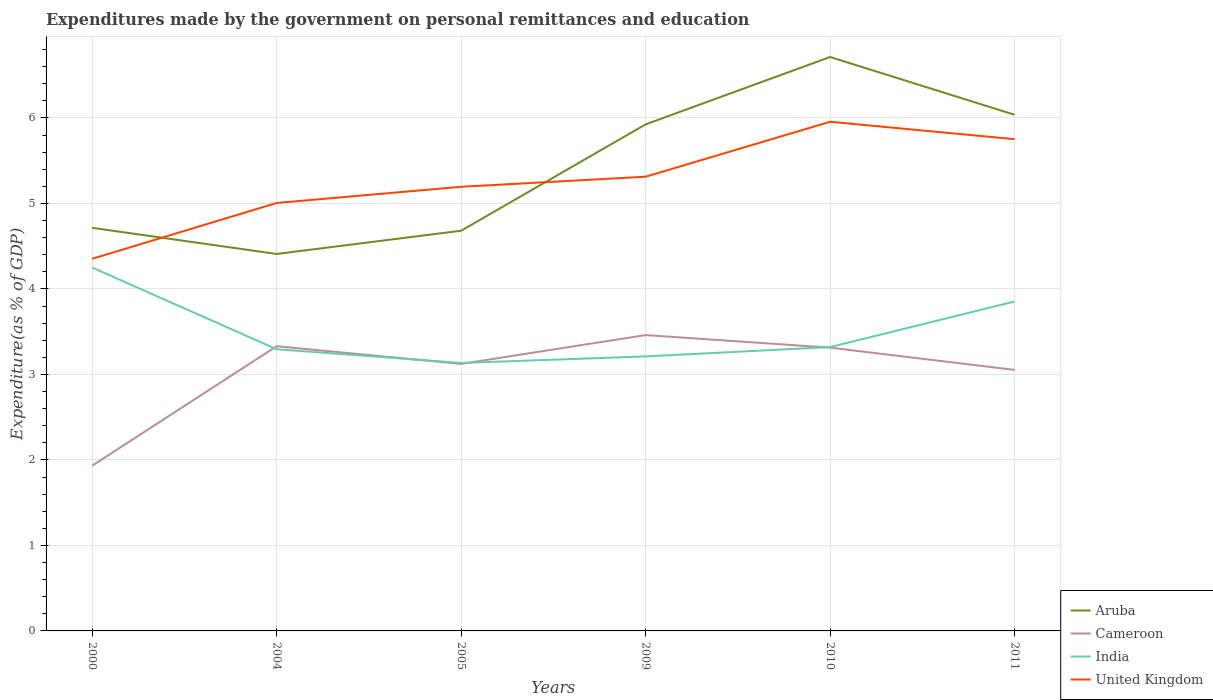How many different coloured lines are there?
Your response must be concise. 4. Across all years, what is the maximum expenditures made by the government on personal remittances and education in United Kingdom?
Your answer should be very brief. 4.35. In which year was the expenditures made by the government on personal remittances and education in India maximum?
Provide a short and direct response. 2005. What is the total expenditures made by the government on personal remittances and education in India in the graph?
Ensure brevity in your answer.  -0.11. What is the difference between the highest and the second highest expenditures made by the government on personal remittances and education in Cameroon?
Provide a succinct answer. 1.53. Is the expenditures made by the government on personal remittances and education in Cameroon strictly greater than the expenditures made by the government on personal remittances and education in India over the years?
Keep it short and to the point. No. How many lines are there?
Keep it short and to the point. 4. What is the difference between two consecutive major ticks on the Y-axis?
Ensure brevity in your answer.  1. Does the graph contain any zero values?
Your answer should be very brief. No. Where does the legend appear in the graph?
Give a very brief answer. Bottom right. How are the legend labels stacked?
Provide a succinct answer. Vertical. What is the title of the graph?
Offer a very short reply. Expenditures made by the government on personal remittances and education. Does "Ukraine" appear as one of the legend labels in the graph?
Ensure brevity in your answer.  No. What is the label or title of the X-axis?
Your answer should be compact. Years. What is the label or title of the Y-axis?
Offer a very short reply. Expenditure(as % of GDP). What is the Expenditure(as % of GDP) in Aruba in 2000?
Offer a very short reply. 4.71. What is the Expenditure(as % of GDP) in Cameroon in 2000?
Your answer should be very brief. 1.93. What is the Expenditure(as % of GDP) of India in 2000?
Give a very brief answer. 4.25. What is the Expenditure(as % of GDP) of United Kingdom in 2000?
Give a very brief answer. 4.35. What is the Expenditure(as % of GDP) in Aruba in 2004?
Provide a short and direct response. 4.41. What is the Expenditure(as % of GDP) of Cameroon in 2004?
Your answer should be very brief. 3.33. What is the Expenditure(as % of GDP) in India in 2004?
Make the answer very short. 3.29. What is the Expenditure(as % of GDP) in United Kingdom in 2004?
Provide a short and direct response. 5.01. What is the Expenditure(as % of GDP) of Aruba in 2005?
Ensure brevity in your answer.  4.68. What is the Expenditure(as % of GDP) of Cameroon in 2005?
Keep it short and to the point. 3.12. What is the Expenditure(as % of GDP) of India in 2005?
Offer a very short reply. 3.13. What is the Expenditure(as % of GDP) in United Kingdom in 2005?
Your answer should be compact. 5.19. What is the Expenditure(as % of GDP) in Aruba in 2009?
Give a very brief answer. 5.92. What is the Expenditure(as % of GDP) of Cameroon in 2009?
Ensure brevity in your answer.  3.46. What is the Expenditure(as % of GDP) of India in 2009?
Provide a succinct answer. 3.21. What is the Expenditure(as % of GDP) in United Kingdom in 2009?
Make the answer very short. 5.31. What is the Expenditure(as % of GDP) in Aruba in 2010?
Provide a short and direct response. 6.71. What is the Expenditure(as % of GDP) in Cameroon in 2010?
Your response must be concise. 3.31. What is the Expenditure(as % of GDP) in India in 2010?
Give a very brief answer. 3.32. What is the Expenditure(as % of GDP) of United Kingdom in 2010?
Provide a short and direct response. 5.95. What is the Expenditure(as % of GDP) of Aruba in 2011?
Offer a terse response. 6.04. What is the Expenditure(as % of GDP) of Cameroon in 2011?
Provide a succinct answer. 3.05. What is the Expenditure(as % of GDP) in India in 2011?
Provide a short and direct response. 3.85. What is the Expenditure(as % of GDP) of United Kingdom in 2011?
Your answer should be compact. 5.75. Across all years, what is the maximum Expenditure(as % of GDP) of Aruba?
Your answer should be compact. 6.71. Across all years, what is the maximum Expenditure(as % of GDP) in Cameroon?
Make the answer very short. 3.46. Across all years, what is the maximum Expenditure(as % of GDP) of India?
Your response must be concise. 4.25. Across all years, what is the maximum Expenditure(as % of GDP) in United Kingdom?
Offer a terse response. 5.95. Across all years, what is the minimum Expenditure(as % of GDP) in Aruba?
Your response must be concise. 4.41. Across all years, what is the minimum Expenditure(as % of GDP) in Cameroon?
Your response must be concise. 1.93. Across all years, what is the minimum Expenditure(as % of GDP) in India?
Offer a terse response. 3.13. Across all years, what is the minimum Expenditure(as % of GDP) of United Kingdom?
Make the answer very short. 4.35. What is the total Expenditure(as % of GDP) in Aruba in the graph?
Ensure brevity in your answer.  32.48. What is the total Expenditure(as % of GDP) of Cameroon in the graph?
Keep it short and to the point. 18.21. What is the total Expenditure(as % of GDP) of India in the graph?
Give a very brief answer. 21.06. What is the total Expenditure(as % of GDP) of United Kingdom in the graph?
Keep it short and to the point. 31.57. What is the difference between the Expenditure(as % of GDP) of Aruba in 2000 and that in 2004?
Your answer should be compact. 0.31. What is the difference between the Expenditure(as % of GDP) in Cameroon in 2000 and that in 2004?
Offer a very short reply. -1.4. What is the difference between the Expenditure(as % of GDP) in India in 2000 and that in 2004?
Your answer should be compact. 0.96. What is the difference between the Expenditure(as % of GDP) in United Kingdom in 2000 and that in 2004?
Give a very brief answer. -0.65. What is the difference between the Expenditure(as % of GDP) in Aruba in 2000 and that in 2005?
Your answer should be compact. 0.03. What is the difference between the Expenditure(as % of GDP) in Cameroon in 2000 and that in 2005?
Provide a short and direct response. -1.19. What is the difference between the Expenditure(as % of GDP) in India in 2000 and that in 2005?
Your response must be concise. 1.12. What is the difference between the Expenditure(as % of GDP) in United Kingdom in 2000 and that in 2005?
Ensure brevity in your answer.  -0.84. What is the difference between the Expenditure(as % of GDP) of Aruba in 2000 and that in 2009?
Your answer should be very brief. -1.21. What is the difference between the Expenditure(as % of GDP) in Cameroon in 2000 and that in 2009?
Make the answer very short. -1.53. What is the difference between the Expenditure(as % of GDP) in India in 2000 and that in 2009?
Your answer should be compact. 1.04. What is the difference between the Expenditure(as % of GDP) of United Kingdom in 2000 and that in 2009?
Ensure brevity in your answer.  -0.96. What is the difference between the Expenditure(as % of GDP) in Aruba in 2000 and that in 2010?
Your answer should be compact. -2. What is the difference between the Expenditure(as % of GDP) in Cameroon in 2000 and that in 2010?
Your response must be concise. -1.38. What is the difference between the Expenditure(as % of GDP) of India in 2000 and that in 2010?
Your response must be concise. 0.93. What is the difference between the Expenditure(as % of GDP) in United Kingdom in 2000 and that in 2010?
Ensure brevity in your answer.  -1.6. What is the difference between the Expenditure(as % of GDP) of Aruba in 2000 and that in 2011?
Offer a very short reply. -1.32. What is the difference between the Expenditure(as % of GDP) in Cameroon in 2000 and that in 2011?
Your answer should be very brief. -1.12. What is the difference between the Expenditure(as % of GDP) of India in 2000 and that in 2011?
Make the answer very short. 0.4. What is the difference between the Expenditure(as % of GDP) of United Kingdom in 2000 and that in 2011?
Your response must be concise. -1.4. What is the difference between the Expenditure(as % of GDP) of Aruba in 2004 and that in 2005?
Provide a succinct answer. -0.27. What is the difference between the Expenditure(as % of GDP) of Cameroon in 2004 and that in 2005?
Your response must be concise. 0.21. What is the difference between the Expenditure(as % of GDP) in India in 2004 and that in 2005?
Your response must be concise. 0.16. What is the difference between the Expenditure(as % of GDP) in United Kingdom in 2004 and that in 2005?
Offer a terse response. -0.19. What is the difference between the Expenditure(as % of GDP) in Aruba in 2004 and that in 2009?
Make the answer very short. -1.52. What is the difference between the Expenditure(as % of GDP) in Cameroon in 2004 and that in 2009?
Offer a terse response. -0.13. What is the difference between the Expenditure(as % of GDP) in India in 2004 and that in 2009?
Make the answer very short. 0.08. What is the difference between the Expenditure(as % of GDP) of United Kingdom in 2004 and that in 2009?
Keep it short and to the point. -0.31. What is the difference between the Expenditure(as % of GDP) in Aruba in 2004 and that in 2010?
Keep it short and to the point. -2.3. What is the difference between the Expenditure(as % of GDP) of Cameroon in 2004 and that in 2010?
Ensure brevity in your answer.  0.02. What is the difference between the Expenditure(as % of GDP) in India in 2004 and that in 2010?
Provide a succinct answer. -0.02. What is the difference between the Expenditure(as % of GDP) in United Kingdom in 2004 and that in 2010?
Your answer should be very brief. -0.95. What is the difference between the Expenditure(as % of GDP) of Aruba in 2004 and that in 2011?
Your answer should be compact. -1.63. What is the difference between the Expenditure(as % of GDP) of Cameroon in 2004 and that in 2011?
Keep it short and to the point. 0.28. What is the difference between the Expenditure(as % of GDP) of India in 2004 and that in 2011?
Offer a terse response. -0.56. What is the difference between the Expenditure(as % of GDP) in United Kingdom in 2004 and that in 2011?
Make the answer very short. -0.75. What is the difference between the Expenditure(as % of GDP) in Aruba in 2005 and that in 2009?
Provide a succinct answer. -1.24. What is the difference between the Expenditure(as % of GDP) of Cameroon in 2005 and that in 2009?
Give a very brief answer. -0.34. What is the difference between the Expenditure(as % of GDP) in India in 2005 and that in 2009?
Provide a short and direct response. -0.08. What is the difference between the Expenditure(as % of GDP) of United Kingdom in 2005 and that in 2009?
Provide a succinct answer. -0.12. What is the difference between the Expenditure(as % of GDP) in Aruba in 2005 and that in 2010?
Your answer should be compact. -2.03. What is the difference between the Expenditure(as % of GDP) in Cameroon in 2005 and that in 2010?
Offer a terse response. -0.19. What is the difference between the Expenditure(as % of GDP) of India in 2005 and that in 2010?
Your answer should be very brief. -0.19. What is the difference between the Expenditure(as % of GDP) in United Kingdom in 2005 and that in 2010?
Ensure brevity in your answer.  -0.76. What is the difference between the Expenditure(as % of GDP) of Aruba in 2005 and that in 2011?
Provide a short and direct response. -1.36. What is the difference between the Expenditure(as % of GDP) of Cameroon in 2005 and that in 2011?
Provide a short and direct response. 0.07. What is the difference between the Expenditure(as % of GDP) of India in 2005 and that in 2011?
Make the answer very short. -0.72. What is the difference between the Expenditure(as % of GDP) of United Kingdom in 2005 and that in 2011?
Your answer should be compact. -0.56. What is the difference between the Expenditure(as % of GDP) of Aruba in 2009 and that in 2010?
Provide a succinct answer. -0.79. What is the difference between the Expenditure(as % of GDP) of Cameroon in 2009 and that in 2010?
Provide a succinct answer. 0.15. What is the difference between the Expenditure(as % of GDP) in India in 2009 and that in 2010?
Ensure brevity in your answer.  -0.11. What is the difference between the Expenditure(as % of GDP) in United Kingdom in 2009 and that in 2010?
Provide a succinct answer. -0.64. What is the difference between the Expenditure(as % of GDP) in Aruba in 2009 and that in 2011?
Ensure brevity in your answer.  -0.11. What is the difference between the Expenditure(as % of GDP) in Cameroon in 2009 and that in 2011?
Provide a succinct answer. 0.41. What is the difference between the Expenditure(as % of GDP) of India in 2009 and that in 2011?
Keep it short and to the point. -0.64. What is the difference between the Expenditure(as % of GDP) of United Kingdom in 2009 and that in 2011?
Offer a very short reply. -0.44. What is the difference between the Expenditure(as % of GDP) of Aruba in 2010 and that in 2011?
Give a very brief answer. 0.68. What is the difference between the Expenditure(as % of GDP) in Cameroon in 2010 and that in 2011?
Give a very brief answer. 0.26. What is the difference between the Expenditure(as % of GDP) in India in 2010 and that in 2011?
Make the answer very short. -0.53. What is the difference between the Expenditure(as % of GDP) in United Kingdom in 2010 and that in 2011?
Make the answer very short. 0.2. What is the difference between the Expenditure(as % of GDP) in Aruba in 2000 and the Expenditure(as % of GDP) in Cameroon in 2004?
Your answer should be compact. 1.38. What is the difference between the Expenditure(as % of GDP) in Aruba in 2000 and the Expenditure(as % of GDP) in India in 2004?
Your answer should be compact. 1.42. What is the difference between the Expenditure(as % of GDP) in Aruba in 2000 and the Expenditure(as % of GDP) in United Kingdom in 2004?
Offer a terse response. -0.29. What is the difference between the Expenditure(as % of GDP) in Cameroon in 2000 and the Expenditure(as % of GDP) in India in 2004?
Your response must be concise. -1.36. What is the difference between the Expenditure(as % of GDP) of Cameroon in 2000 and the Expenditure(as % of GDP) of United Kingdom in 2004?
Provide a short and direct response. -3.07. What is the difference between the Expenditure(as % of GDP) of India in 2000 and the Expenditure(as % of GDP) of United Kingdom in 2004?
Give a very brief answer. -0.76. What is the difference between the Expenditure(as % of GDP) of Aruba in 2000 and the Expenditure(as % of GDP) of Cameroon in 2005?
Your answer should be compact. 1.59. What is the difference between the Expenditure(as % of GDP) in Aruba in 2000 and the Expenditure(as % of GDP) in India in 2005?
Offer a very short reply. 1.58. What is the difference between the Expenditure(as % of GDP) of Aruba in 2000 and the Expenditure(as % of GDP) of United Kingdom in 2005?
Offer a very short reply. -0.48. What is the difference between the Expenditure(as % of GDP) of Cameroon in 2000 and the Expenditure(as % of GDP) of India in 2005?
Offer a terse response. -1.2. What is the difference between the Expenditure(as % of GDP) in Cameroon in 2000 and the Expenditure(as % of GDP) in United Kingdom in 2005?
Provide a short and direct response. -3.26. What is the difference between the Expenditure(as % of GDP) in India in 2000 and the Expenditure(as % of GDP) in United Kingdom in 2005?
Offer a terse response. -0.94. What is the difference between the Expenditure(as % of GDP) of Aruba in 2000 and the Expenditure(as % of GDP) of Cameroon in 2009?
Make the answer very short. 1.25. What is the difference between the Expenditure(as % of GDP) in Aruba in 2000 and the Expenditure(as % of GDP) in India in 2009?
Provide a short and direct response. 1.5. What is the difference between the Expenditure(as % of GDP) in Aruba in 2000 and the Expenditure(as % of GDP) in United Kingdom in 2009?
Your answer should be compact. -0.6. What is the difference between the Expenditure(as % of GDP) in Cameroon in 2000 and the Expenditure(as % of GDP) in India in 2009?
Offer a terse response. -1.28. What is the difference between the Expenditure(as % of GDP) of Cameroon in 2000 and the Expenditure(as % of GDP) of United Kingdom in 2009?
Provide a short and direct response. -3.38. What is the difference between the Expenditure(as % of GDP) in India in 2000 and the Expenditure(as % of GDP) in United Kingdom in 2009?
Ensure brevity in your answer.  -1.06. What is the difference between the Expenditure(as % of GDP) of Aruba in 2000 and the Expenditure(as % of GDP) of Cameroon in 2010?
Offer a very short reply. 1.4. What is the difference between the Expenditure(as % of GDP) in Aruba in 2000 and the Expenditure(as % of GDP) in India in 2010?
Offer a terse response. 1.4. What is the difference between the Expenditure(as % of GDP) of Aruba in 2000 and the Expenditure(as % of GDP) of United Kingdom in 2010?
Your answer should be very brief. -1.24. What is the difference between the Expenditure(as % of GDP) of Cameroon in 2000 and the Expenditure(as % of GDP) of India in 2010?
Offer a very short reply. -1.39. What is the difference between the Expenditure(as % of GDP) of Cameroon in 2000 and the Expenditure(as % of GDP) of United Kingdom in 2010?
Provide a short and direct response. -4.02. What is the difference between the Expenditure(as % of GDP) in India in 2000 and the Expenditure(as % of GDP) in United Kingdom in 2010?
Offer a very short reply. -1.7. What is the difference between the Expenditure(as % of GDP) of Aruba in 2000 and the Expenditure(as % of GDP) of Cameroon in 2011?
Provide a short and direct response. 1.66. What is the difference between the Expenditure(as % of GDP) of Aruba in 2000 and the Expenditure(as % of GDP) of India in 2011?
Keep it short and to the point. 0.86. What is the difference between the Expenditure(as % of GDP) in Aruba in 2000 and the Expenditure(as % of GDP) in United Kingdom in 2011?
Your response must be concise. -1.04. What is the difference between the Expenditure(as % of GDP) in Cameroon in 2000 and the Expenditure(as % of GDP) in India in 2011?
Your response must be concise. -1.92. What is the difference between the Expenditure(as % of GDP) in Cameroon in 2000 and the Expenditure(as % of GDP) in United Kingdom in 2011?
Provide a short and direct response. -3.82. What is the difference between the Expenditure(as % of GDP) in India in 2000 and the Expenditure(as % of GDP) in United Kingdom in 2011?
Offer a terse response. -1.5. What is the difference between the Expenditure(as % of GDP) in Aruba in 2004 and the Expenditure(as % of GDP) in Cameroon in 2005?
Your response must be concise. 1.29. What is the difference between the Expenditure(as % of GDP) of Aruba in 2004 and the Expenditure(as % of GDP) of India in 2005?
Make the answer very short. 1.28. What is the difference between the Expenditure(as % of GDP) in Aruba in 2004 and the Expenditure(as % of GDP) in United Kingdom in 2005?
Make the answer very short. -0.79. What is the difference between the Expenditure(as % of GDP) of Cameroon in 2004 and the Expenditure(as % of GDP) of India in 2005?
Ensure brevity in your answer.  0.2. What is the difference between the Expenditure(as % of GDP) in Cameroon in 2004 and the Expenditure(as % of GDP) in United Kingdom in 2005?
Offer a very short reply. -1.86. What is the difference between the Expenditure(as % of GDP) in India in 2004 and the Expenditure(as % of GDP) in United Kingdom in 2005?
Your answer should be compact. -1.9. What is the difference between the Expenditure(as % of GDP) in Aruba in 2004 and the Expenditure(as % of GDP) in Cameroon in 2009?
Provide a succinct answer. 0.95. What is the difference between the Expenditure(as % of GDP) of Aruba in 2004 and the Expenditure(as % of GDP) of India in 2009?
Ensure brevity in your answer.  1.2. What is the difference between the Expenditure(as % of GDP) in Aruba in 2004 and the Expenditure(as % of GDP) in United Kingdom in 2009?
Ensure brevity in your answer.  -0.9. What is the difference between the Expenditure(as % of GDP) in Cameroon in 2004 and the Expenditure(as % of GDP) in India in 2009?
Your answer should be compact. 0.12. What is the difference between the Expenditure(as % of GDP) of Cameroon in 2004 and the Expenditure(as % of GDP) of United Kingdom in 2009?
Ensure brevity in your answer.  -1.98. What is the difference between the Expenditure(as % of GDP) in India in 2004 and the Expenditure(as % of GDP) in United Kingdom in 2009?
Your answer should be compact. -2.02. What is the difference between the Expenditure(as % of GDP) in Aruba in 2004 and the Expenditure(as % of GDP) in Cameroon in 2010?
Ensure brevity in your answer.  1.1. What is the difference between the Expenditure(as % of GDP) of Aruba in 2004 and the Expenditure(as % of GDP) of India in 2010?
Keep it short and to the point. 1.09. What is the difference between the Expenditure(as % of GDP) of Aruba in 2004 and the Expenditure(as % of GDP) of United Kingdom in 2010?
Provide a short and direct response. -1.55. What is the difference between the Expenditure(as % of GDP) of Cameroon in 2004 and the Expenditure(as % of GDP) of India in 2010?
Ensure brevity in your answer.  0.01. What is the difference between the Expenditure(as % of GDP) in Cameroon in 2004 and the Expenditure(as % of GDP) in United Kingdom in 2010?
Offer a very short reply. -2.63. What is the difference between the Expenditure(as % of GDP) of India in 2004 and the Expenditure(as % of GDP) of United Kingdom in 2010?
Make the answer very short. -2.66. What is the difference between the Expenditure(as % of GDP) of Aruba in 2004 and the Expenditure(as % of GDP) of Cameroon in 2011?
Your response must be concise. 1.36. What is the difference between the Expenditure(as % of GDP) of Aruba in 2004 and the Expenditure(as % of GDP) of India in 2011?
Your answer should be compact. 0.56. What is the difference between the Expenditure(as % of GDP) of Aruba in 2004 and the Expenditure(as % of GDP) of United Kingdom in 2011?
Offer a terse response. -1.34. What is the difference between the Expenditure(as % of GDP) of Cameroon in 2004 and the Expenditure(as % of GDP) of India in 2011?
Provide a succinct answer. -0.52. What is the difference between the Expenditure(as % of GDP) in Cameroon in 2004 and the Expenditure(as % of GDP) in United Kingdom in 2011?
Your answer should be very brief. -2.42. What is the difference between the Expenditure(as % of GDP) of India in 2004 and the Expenditure(as % of GDP) of United Kingdom in 2011?
Provide a succinct answer. -2.46. What is the difference between the Expenditure(as % of GDP) of Aruba in 2005 and the Expenditure(as % of GDP) of Cameroon in 2009?
Your answer should be compact. 1.22. What is the difference between the Expenditure(as % of GDP) of Aruba in 2005 and the Expenditure(as % of GDP) of India in 2009?
Your answer should be very brief. 1.47. What is the difference between the Expenditure(as % of GDP) of Aruba in 2005 and the Expenditure(as % of GDP) of United Kingdom in 2009?
Provide a succinct answer. -0.63. What is the difference between the Expenditure(as % of GDP) of Cameroon in 2005 and the Expenditure(as % of GDP) of India in 2009?
Offer a terse response. -0.09. What is the difference between the Expenditure(as % of GDP) of Cameroon in 2005 and the Expenditure(as % of GDP) of United Kingdom in 2009?
Make the answer very short. -2.19. What is the difference between the Expenditure(as % of GDP) of India in 2005 and the Expenditure(as % of GDP) of United Kingdom in 2009?
Your answer should be very brief. -2.18. What is the difference between the Expenditure(as % of GDP) in Aruba in 2005 and the Expenditure(as % of GDP) in Cameroon in 2010?
Provide a short and direct response. 1.37. What is the difference between the Expenditure(as % of GDP) in Aruba in 2005 and the Expenditure(as % of GDP) in India in 2010?
Provide a succinct answer. 1.36. What is the difference between the Expenditure(as % of GDP) in Aruba in 2005 and the Expenditure(as % of GDP) in United Kingdom in 2010?
Offer a terse response. -1.27. What is the difference between the Expenditure(as % of GDP) of Cameroon in 2005 and the Expenditure(as % of GDP) of India in 2010?
Your answer should be compact. -0.2. What is the difference between the Expenditure(as % of GDP) in Cameroon in 2005 and the Expenditure(as % of GDP) in United Kingdom in 2010?
Your response must be concise. -2.83. What is the difference between the Expenditure(as % of GDP) in India in 2005 and the Expenditure(as % of GDP) in United Kingdom in 2010?
Ensure brevity in your answer.  -2.82. What is the difference between the Expenditure(as % of GDP) of Aruba in 2005 and the Expenditure(as % of GDP) of Cameroon in 2011?
Give a very brief answer. 1.63. What is the difference between the Expenditure(as % of GDP) in Aruba in 2005 and the Expenditure(as % of GDP) in India in 2011?
Give a very brief answer. 0.83. What is the difference between the Expenditure(as % of GDP) in Aruba in 2005 and the Expenditure(as % of GDP) in United Kingdom in 2011?
Ensure brevity in your answer.  -1.07. What is the difference between the Expenditure(as % of GDP) in Cameroon in 2005 and the Expenditure(as % of GDP) in India in 2011?
Your response must be concise. -0.73. What is the difference between the Expenditure(as % of GDP) in Cameroon in 2005 and the Expenditure(as % of GDP) in United Kingdom in 2011?
Offer a very short reply. -2.63. What is the difference between the Expenditure(as % of GDP) of India in 2005 and the Expenditure(as % of GDP) of United Kingdom in 2011?
Your answer should be compact. -2.62. What is the difference between the Expenditure(as % of GDP) in Aruba in 2009 and the Expenditure(as % of GDP) in Cameroon in 2010?
Your answer should be compact. 2.61. What is the difference between the Expenditure(as % of GDP) in Aruba in 2009 and the Expenditure(as % of GDP) in India in 2010?
Provide a succinct answer. 2.61. What is the difference between the Expenditure(as % of GDP) in Aruba in 2009 and the Expenditure(as % of GDP) in United Kingdom in 2010?
Make the answer very short. -0.03. What is the difference between the Expenditure(as % of GDP) of Cameroon in 2009 and the Expenditure(as % of GDP) of India in 2010?
Keep it short and to the point. 0.14. What is the difference between the Expenditure(as % of GDP) in Cameroon in 2009 and the Expenditure(as % of GDP) in United Kingdom in 2010?
Make the answer very short. -2.49. What is the difference between the Expenditure(as % of GDP) in India in 2009 and the Expenditure(as % of GDP) in United Kingdom in 2010?
Your answer should be compact. -2.74. What is the difference between the Expenditure(as % of GDP) of Aruba in 2009 and the Expenditure(as % of GDP) of Cameroon in 2011?
Your answer should be compact. 2.87. What is the difference between the Expenditure(as % of GDP) in Aruba in 2009 and the Expenditure(as % of GDP) in India in 2011?
Make the answer very short. 2.07. What is the difference between the Expenditure(as % of GDP) of Aruba in 2009 and the Expenditure(as % of GDP) of United Kingdom in 2011?
Your answer should be very brief. 0.17. What is the difference between the Expenditure(as % of GDP) in Cameroon in 2009 and the Expenditure(as % of GDP) in India in 2011?
Ensure brevity in your answer.  -0.39. What is the difference between the Expenditure(as % of GDP) of Cameroon in 2009 and the Expenditure(as % of GDP) of United Kingdom in 2011?
Offer a terse response. -2.29. What is the difference between the Expenditure(as % of GDP) of India in 2009 and the Expenditure(as % of GDP) of United Kingdom in 2011?
Your answer should be very brief. -2.54. What is the difference between the Expenditure(as % of GDP) of Aruba in 2010 and the Expenditure(as % of GDP) of Cameroon in 2011?
Your answer should be very brief. 3.66. What is the difference between the Expenditure(as % of GDP) in Aruba in 2010 and the Expenditure(as % of GDP) in India in 2011?
Give a very brief answer. 2.86. What is the difference between the Expenditure(as % of GDP) in Aruba in 2010 and the Expenditure(as % of GDP) in United Kingdom in 2011?
Your answer should be compact. 0.96. What is the difference between the Expenditure(as % of GDP) of Cameroon in 2010 and the Expenditure(as % of GDP) of India in 2011?
Provide a succinct answer. -0.54. What is the difference between the Expenditure(as % of GDP) in Cameroon in 2010 and the Expenditure(as % of GDP) in United Kingdom in 2011?
Provide a short and direct response. -2.44. What is the difference between the Expenditure(as % of GDP) in India in 2010 and the Expenditure(as % of GDP) in United Kingdom in 2011?
Provide a succinct answer. -2.43. What is the average Expenditure(as % of GDP) in Aruba per year?
Make the answer very short. 5.41. What is the average Expenditure(as % of GDP) in Cameroon per year?
Offer a terse response. 3.04. What is the average Expenditure(as % of GDP) in India per year?
Give a very brief answer. 3.51. What is the average Expenditure(as % of GDP) of United Kingdom per year?
Offer a terse response. 5.26. In the year 2000, what is the difference between the Expenditure(as % of GDP) in Aruba and Expenditure(as % of GDP) in Cameroon?
Ensure brevity in your answer.  2.78. In the year 2000, what is the difference between the Expenditure(as % of GDP) of Aruba and Expenditure(as % of GDP) of India?
Your response must be concise. 0.46. In the year 2000, what is the difference between the Expenditure(as % of GDP) of Aruba and Expenditure(as % of GDP) of United Kingdom?
Keep it short and to the point. 0.36. In the year 2000, what is the difference between the Expenditure(as % of GDP) of Cameroon and Expenditure(as % of GDP) of India?
Keep it short and to the point. -2.32. In the year 2000, what is the difference between the Expenditure(as % of GDP) of Cameroon and Expenditure(as % of GDP) of United Kingdom?
Provide a short and direct response. -2.42. In the year 2000, what is the difference between the Expenditure(as % of GDP) in India and Expenditure(as % of GDP) in United Kingdom?
Your answer should be compact. -0.1. In the year 2004, what is the difference between the Expenditure(as % of GDP) in Aruba and Expenditure(as % of GDP) in Cameroon?
Provide a succinct answer. 1.08. In the year 2004, what is the difference between the Expenditure(as % of GDP) in Aruba and Expenditure(as % of GDP) in India?
Provide a short and direct response. 1.11. In the year 2004, what is the difference between the Expenditure(as % of GDP) of Aruba and Expenditure(as % of GDP) of United Kingdom?
Provide a short and direct response. -0.6. In the year 2004, what is the difference between the Expenditure(as % of GDP) in Cameroon and Expenditure(as % of GDP) in India?
Your answer should be very brief. 0.04. In the year 2004, what is the difference between the Expenditure(as % of GDP) of Cameroon and Expenditure(as % of GDP) of United Kingdom?
Keep it short and to the point. -1.68. In the year 2004, what is the difference between the Expenditure(as % of GDP) in India and Expenditure(as % of GDP) in United Kingdom?
Offer a very short reply. -1.71. In the year 2005, what is the difference between the Expenditure(as % of GDP) of Aruba and Expenditure(as % of GDP) of Cameroon?
Provide a succinct answer. 1.56. In the year 2005, what is the difference between the Expenditure(as % of GDP) in Aruba and Expenditure(as % of GDP) in India?
Provide a succinct answer. 1.55. In the year 2005, what is the difference between the Expenditure(as % of GDP) in Aruba and Expenditure(as % of GDP) in United Kingdom?
Your answer should be compact. -0.51. In the year 2005, what is the difference between the Expenditure(as % of GDP) in Cameroon and Expenditure(as % of GDP) in India?
Your answer should be very brief. -0.01. In the year 2005, what is the difference between the Expenditure(as % of GDP) of Cameroon and Expenditure(as % of GDP) of United Kingdom?
Provide a short and direct response. -2.07. In the year 2005, what is the difference between the Expenditure(as % of GDP) in India and Expenditure(as % of GDP) in United Kingdom?
Your response must be concise. -2.06. In the year 2009, what is the difference between the Expenditure(as % of GDP) of Aruba and Expenditure(as % of GDP) of Cameroon?
Your response must be concise. 2.46. In the year 2009, what is the difference between the Expenditure(as % of GDP) in Aruba and Expenditure(as % of GDP) in India?
Offer a terse response. 2.71. In the year 2009, what is the difference between the Expenditure(as % of GDP) of Aruba and Expenditure(as % of GDP) of United Kingdom?
Provide a succinct answer. 0.61. In the year 2009, what is the difference between the Expenditure(as % of GDP) of Cameroon and Expenditure(as % of GDP) of India?
Provide a succinct answer. 0.25. In the year 2009, what is the difference between the Expenditure(as % of GDP) in Cameroon and Expenditure(as % of GDP) in United Kingdom?
Keep it short and to the point. -1.85. In the year 2009, what is the difference between the Expenditure(as % of GDP) in India and Expenditure(as % of GDP) in United Kingdom?
Give a very brief answer. -2.1. In the year 2010, what is the difference between the Expenditure(as % of GDP) of Aruba and Expenditure(as % of GDP) of Cameroon?
Make the answer very short. 3.4. In the year 2010, what is the difference between the Expenditure(as % of GDP) in Aruba and Expenditure(as % of GDP) in India?
Your response must be concise. 3.39. In the year 2010, what is the difference between the Expenditure(as % of GDP) in Aruba and Expenditure(as % of GDP) in United Kingdom?
Your answer should be compact. 0.76. In the year 2010, what is the difference between the Expenditure(as % of GDP) of Cameroon and Expenditure(as % of GDP) of India?
Your response must be concise. -0.01. In the year 2010, what is the difference between the Expenditure(as % of GDP) in Cameroon and Expenditure(as % of GDP) in United Kingdom?
Provide a short and direct response. -2.64. In the year 2010, what is the difference between the Expenditure(as % of GDP) of India and Expenditure(as % of GDP) of United Kingdom?
Your answer should be very brief. -2.64. In the year 2011, what is the difference between the Expenditure(as % of GDP) in Aruba and Expenditure(as % of GDP) in Cameroon?
Your answer should be very brief. 2.98. In the year 2011, what is the difference between the Expenditure(as % of GDP) of Aruba and Expenditure(as % of GDP) of India?
Your answer should be compact. 2.18. In the year 2011, what is the difference between the Expenditure(as % of GDP) of Aruba and Expenditure(as % of GDP) of United Kingdom?
Keep it short and to the point. 0.29. In the year 2011, what is the difference between the Expenditure(as % of GDP) of Cameroon and Expenditure(as % of GDP) of India?
Offer a very short reply. -0.8. In the year 2011, what is the difference between the Expenditure(as % of GDP) of Cameroon and Expenditure(as % of GDP) of United Kingdom?
Keep it short and to the point. -2.7. In the year 2011, what is the difference between the Expenditure(as % of GDP) of India and Expenditure(as % of GDP) of United Kingdom?
Your response must be concise. -1.9. What is the ratio of the Expenditure(as % of GDP) in Aruba in 2000 to that in 2004?
Your response must be concise. 1.07. What is the ratio of the Expenditure(as % of GDP) in Cameroon in 2000 to that in 2004?
Your response must be concise. 0.58. What is the ratio of the Expenditure(as % of GDP) in India in 2000 to that in 2004?
Give a very brief answer. 1.29. What is the ratio of the Expenditure(as % of GDP) of United Kingdom in 2000 to that in 2004?
Offer a terse response. 0.87. What is the ratio of the Expenditure(as % of GDP) of Cameroon in 2000 to that in 2005?
Provide a short and direct response. 0.62. What is the ratio of the Expenditure(as % of GDP) of India in 2000 to that in 2005?
Give a very brief answer. 1.36. What is the ratio of the Expenditure(as % of GDP) in United Kingdom in 2000 to that in 2005?
Your answer should be compact. 0.84. What is the ratio of the Expenditure(as % of GDP) in Aruba in 2000 to that in 2009?
Provide a short and direct response. 0.8. What is the ratio of the Expenditure(as % of GDP) in Cameroon in 2000 to that in 2009?
Your answer should be very brief. 0.56. What is the ratio of the Expenditure(as % of GDP) in India in 2000 to that in 2009?
Give a very brief answer. 1.32. What is the ratio of the Expenditure(as % of GDP) in United Kingdom in 2000 to that in 2009?
Offer a terse response. 0.82. What is the ratio of the Expenditure(as % of GDP) of Aruba in 2000 to that in 2010?
Keep it short and to the point. 0.7. What is the ratio of the Expenditure(as % of GDP) of Cameroon in 2000 to that in 2010?
Provide a short and direct response. 0.58. What is the ratio of the Expenditure(as % of GDP) of India in 2000 to that in 2010?
Your answer should be very brief. 1.28. What is the ratio of the Expenditure(as % of GDP) of United Kingdom in 2000 to that in 2010?
Your answer should be compact. 0.73. What is the ratio of the Expenditure(as % of GDP) of Aruba in 2000 to that in 2011?
Keep it short and to the point. 0.78. What is the ratio of the Expenditure(as % of GDP) of Cameroon in 2000 to that in 2011?
Offer a terse response. 0.63. What is the ratio of the Expenditure(as % of GDP) of India in 2000 to that in 2011?
Keep it short and to the point. 1.1. What is the ratio of the Expenditure(as % of GDP) in United Kingdom in 2000 to that in 2011?
Offer a terse response. 0.76. What is the ratio of the Expenditure(as % of GDP) of Aruba in 2004 to that in 2005?
Keep it short and to the point. 0.94. What is the ratio of the Expenditure(as % of GDP) of Cameroon in 2004 to that in 2005?
Provide a short and direct response. 1.07. What is the ratio of the Expenditure(as % of GDP) in India in 2004 to that in 2005?
Ensure brevity in your answer.  1.05. What is the ratio of the Expenditure(as % of GDP) in United Kingdom in 2004 to that in 2005?
Give a very brief answer. 0.96. What is the ratio of the Expenditure(as % of GDP) of Aruba in 2004 to that in 2009?
Keep it short and to the point. 0.74. What is the ratio of the Expenditure(as % of GDP) of Cameroon in 2004 to that in 2009?
Offer a very short reply. 0.96. What is the ratio of the Expenditure(as % of GDP) in India in 2004 to that in 2009?
Keep it short and to the point. 1.03. What is the ratio of the Expenditure(as % of GDP) of United Kingdom in 2004 to that in 2009?
Give a very brief answer. 0.94. What is the ratio of the Expenditure(as % of GDP) of Aruba in 2004 to that in 2010?
Provide a succinct answer. 0.66. What is the ratio of the Expenditure(as % of GDP) in United Kingdom in 2004 to that in 2010?
Provide a short and direct response. 0.84. What is the ratio of the Expenditure(as % of GDP) of Aruba in 2004 to that in 2011?
Give a very brief answer. 0.73. What is the ratio of the Expenditure(as % of GDP) of Cameroon in 2004 to that in 2011?
Offer a very short reply. 1.09. What is the ratio of the Expenditure(as % of GDP) of India in 2004 to that in 2011?
Make the answer very short. 0.86. What is the ratio of the Expenditure(as % of GDP) of United Kingdom in 2004 to that in 2011?
Your answer should be compact. 0.87. What is the ratio of the Expenditure(as % of GDP) of Aruba in 2005 to that in 2009?
Keep it short and to the point. 0.79. What is the ratio of the Expenditure(as % of GDP) of Cameroon in 2005 to that in 2009?
Your response must be concise. 0.9. What is the ratio of the Expenditure(as % of GDP) of United Kingdom in 2005 to that in 2009?
Your answer should be compact. 0.98. What is the ratio of the Expenditure(as % of GDP) of Aruba in 2005 to that in 2010?
Provide a succinct answer. 0.7. What is the ratio of the Expenditure(as % of GDP) of Cameroon in 2005 to that in 2010?
Offer a very short reply. 0.94. What is the ratio of the Expenditure(as % of GDP) in India in 2005 to that in 2010?
Keep it short and to the point. 0.94. What is the ratio of the Expenditure(as % of GDP) of United Kingdom in 2005 to that in 2010?
Offer a terse response. 0.87. What is the ratio of the Expenditure(as % of GDP) of Aruba in 2005 to that in 2011?
Keep it short and to the point. 0.78. What is the ratio of the Expenditure(as % of GDP) of Cameroon in 2005 to that in 2011?
Give a very brief answer. 1.02. What is the ratio of the Expenditure(as % of GDP) of India in 2005 to that in 2011?
Keep it short and to the point. 0.81. What is the ratio of the Expenditure(as % of GDP) of United Kingdom in 2005 to that in 2011?
Make the answer very short. 0.9. What is the ratio of the Expenditure(as % of GDP) of Aruba in 2009 to that in 2010?
Your answer should be very brief. 0.88. What is the ratio of the Expenditure(as % of GDP) in Cameroon in 2009 to that in 2010?
Give a very brief answer. 1.04. What is the ratio of the Expenditure(as % of GDP) in India in 2009 to that in 2010?
Your response must be concise. 0.97. What is the ratio of the Expenditure(as % of GDP) of United Kingdom in 2009 to that in 2010?
Offer a terse response. 0.89. What is the ratio of the Expenditure(as % of GDP) in Aruba in 2009 to that in 2011?
Keep it short and to the point. 0.98. What is the ratio of the Expenditure(as % of GDP) of Cameroon in 2009 to that in 2011?
Offer a terse response. 1.13. What is the ratio of the Expenditure(as % of GDP) of India in 2009 to that in 2011?
Your answer should be compact. 0.83. What is the ratio of the Expenditure(as % of GDP) in United Kingdom in 2009 to that in 2011?
Make the answer very short. 0.92. What is the ratio of the Expenditure(as % of GDP) in Aruba in 2010 to that in 2011?
Give a very brief answer. 1.11. What is the ratio of the Expenditure(as % of GDP) in Cameroon in 2010 to that in 2011?
Your answer should be very brief. 1.09. What is the ratio of the Expenditure(as % of GDP) of India in 2010 to that in 2011?
Offer a terse response. 0.86. What is the ratio of the Expenditure(as % of GDP) of United Kingdom in 2010 to that in 2011?
Ensure brevity in your answer.  1.04. What is the difference between the highest and the second highest Expenditure(as % of GDP) in Aruba?
Ensure brevity in your answer.  0.68. What is the difference between the highest and the second highest Expenditure(as % of GDP) of Cameroon?
Provide a succinct answer. 0.13. What is the difference between the highest and the second highest Expenditure(as % of GDP) in India?
Offer a very short reply. 0.4. What is the difference between the highest and the second highest Expenditure(as % of GDP) in United Kingdom?
Your response must be concise. 0.2. What is the difference between the highest and the lowest Expenditure(as % of GDP) of Aruba?
Give a very brief answer. 2.3. What is the difference between the highest and the lowest Expenditure(as % of GDP) of Cameroon?
Offer a very short reply. 1.53. What is the difference between the highest and the lowest Expenditure(as % of GDP) of India?
Give a very brief answer. 1.12. What is the difference between the highest and the lowest Expenditure(as % of GDP) of United Kingdom?
Give a very brief answer. 1.6. 